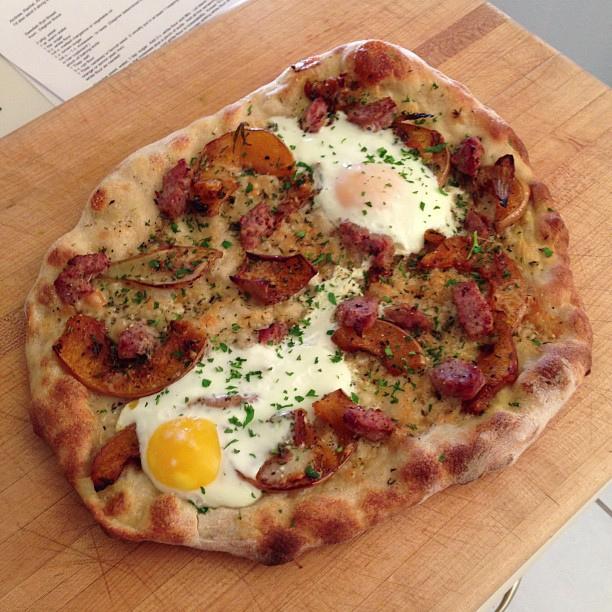What type of pizza is this?
Concise answer only. Breakfast pizza. Are there fried eggs on the pizza?
Answer briefly. Yes. What kind of pizza is this?
Give a very brief answer. Breakfast. Are there bacon pieces included in the food?
Quick response, please. Yes. 